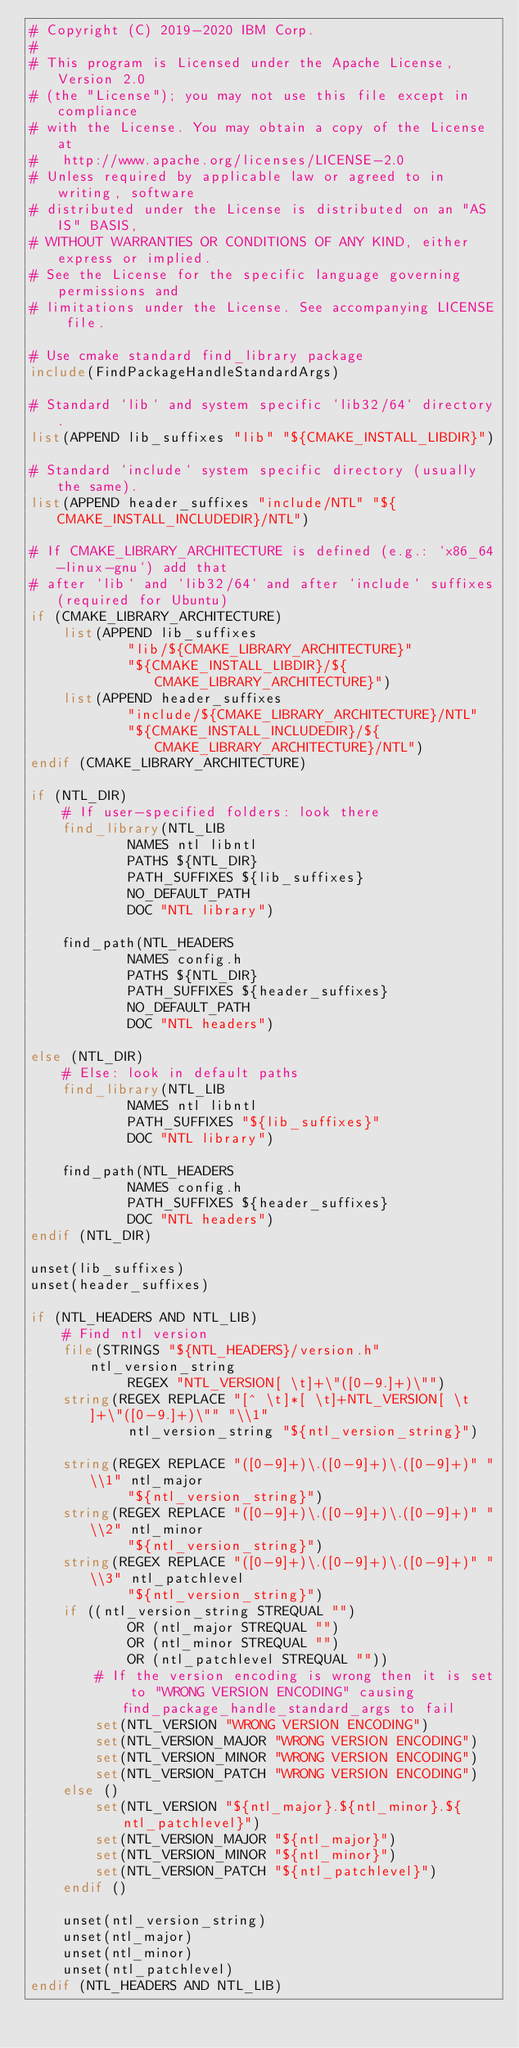<code> <loc_0><loc_0><loc_500><loc_500><_CMake_># Copyright (C) 2019-2020 IBM Corp.
#
# This program is Licensed under the Apache License, Version 2.0
# (the "License"); you may not use this file except in compliance
# with the License. You may obtain a copy of the License at
#   http://www.apache.org/licenses/LICENSE-2.0
# Unless required by applicable law or agreed to in writing, software
# distributed under the License is distributed on an "AS IS" BASIS,
# WITHOUT WARRANTIES OR CONDITIONS OF ANY KIND, either express or implied.
# See the License for the specific language governing permissions and
# limitations under the License. See accompanying LICENSE file.

# Use cmake standard find_library package
include(FindPackageHandleStandardArgs)

# Standard `lib` and system specific `lib32/64` directory.
list(APPEND lib_suffixes "lib" "${CMAKE_INSTALL_LIBDIR}")

# Standard `include` system specific directory (usually the same).
list(APPEND header_suffixes "include/NTL" "${CMAKE_INSTALL_INCLUDEDIR}/NTL")

# If CMAKE_LIBRARY_ARCHITECTURE is defined (e.g.: `x86_64-linux-gnu`) add that
# after `lib` and `lib32/64` and after `include` suffixes(required for Ubuntu)
if (CMAKE_LIBRARY_ARCHITECTURE)
    list(APPEND lib_suffixes
            "lib/${CMAKE_LIBRARY_ARCHITECTURE}"
            "${CMAKE_INSTALL_LIBDIR}/${CMAKE_LIBRARY_ARCHITECTURE}")
    list(APPEND header_suffixes
            "include/${CMAKE_LIBRARY_ARCHITECTURE}/NTL"
            "${CMAKE_INSTALL_INCLUDEDIR}/${CMAKE_LIBRARY_ARCHITECTURE}/NTL")
endif (CMAKE_LIBRARY_ARCHITECTURE)

if (NTL_DIR)
    # If user-specified folders: look there
    find_library(NTL_LIB
            NAMES ntl libntl
            PATHS ${NTL_DIR}
            PATH_SUFFIXES ${lib_suffixes}
            NO_DEFAULT_PATH
            DOC "NTL library")

    find_path(NTL_HEADERS
            NAMES config.h
            PATHS ${NTL_DIR}
            PATH_SUFFIXES ${header_suffixes}
            NO_DEFAULT_PATH
            DOC "NTL headers")

else (NTL_DIR)
    # Else: look in default paths
    find_library(NTL_LIB
            NAMES ntl libntl
            PATH_SUFFIXES "${lib_suffixes}"
            DOC "NTL library")

    find_path(NTL_HEADERS
            NAMES config.h
            PATH_SUFFIXES ${header_suffixes}
            DOC "NTL headers")
endif (NTL_DIR)

unset(lib_suffixes)
unset(header_suffixes)

if (NTL_HEADERS AND NTL_LIB)
    # Find ntl version
    file(STRINGS "${NTL_HEADERS}/version.h" ntl_version_string
            REGEX "NTL_VERSION[ \t]+\"([0-9.]+)\"")
    string(REGEX REPLACE "[^ \t]*[ \t]+NTL_VERSION[ \t]+\"([0-9.]+)\"" "\\1"
            ntl_version_string "${ntl_version_string}")

    string(REGEX REPLACE "([0-9]+)\.([0-9]+)\.([0-9]+)" "\\1" ntl_major
            "${ntl_version_string}")
    string(REGEX REPLACE "([0-9]+)\.([0-9]+)\.([0-9]+)" "\\2" ntl_minor
            "${ntl_version_string}")
    string(REGEX REPLACE "([0-9]+)\.([0-9]+)\.([0-9]+)" "\\3" ntl_patchlevel
            "${ntl_version_string}")
    if ((ntl_version_string STREQUAL "")
            OR (ntl_major STREQUAL "")
            OR (ntl_minor STREQUAL "")
            OR (ntl_patchlevel STREQUAL ""))
        # If the version encoding is wrong then it is set to "WRONG VERSION ENCODING" causing find_package_handle_standard_args to fail
        set(NTL_VERSION "WRONG VERSION ENCODING")
        set(NTL_VERSION_MAJOR "WRONG VERSION ENCODING")
        set(NTL_VERSION_MINOR "WRONG VERSION ENCODING")
        set(NTL_VERSION_PATCH "WRONG VERSION ENCODING")
    else ()
        set(NTL_VERSION "${ntl_major}.${ntl_minor}.${ntl_patchlevel}")
        set(NTL_VERSION_MAJOR "${ntl_major}")
        set(NTL_VERSION_MINOR "${ntl_minor}")
        set(NTL_VERSION_PATCH "${ntl_patchlevel}")
    endif ()

    unset(ntl_version_string)
    unset(ntl_major)
    unset(ntl_minor)
    unset(ntl_patchlevel)
endif (NTL_HEADERS AND NTL_LIB)
</code> 